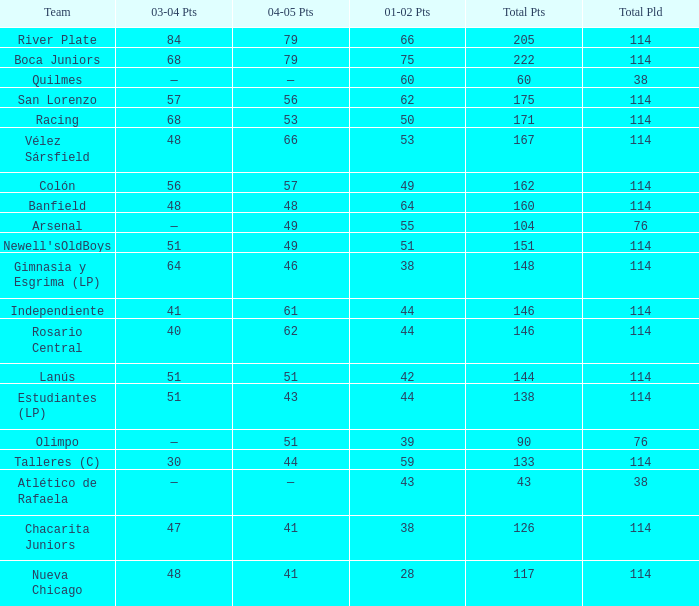Which Team has a Total Pld smaller than 114, and a 2004–05 Pts of 49? Arsenal. 